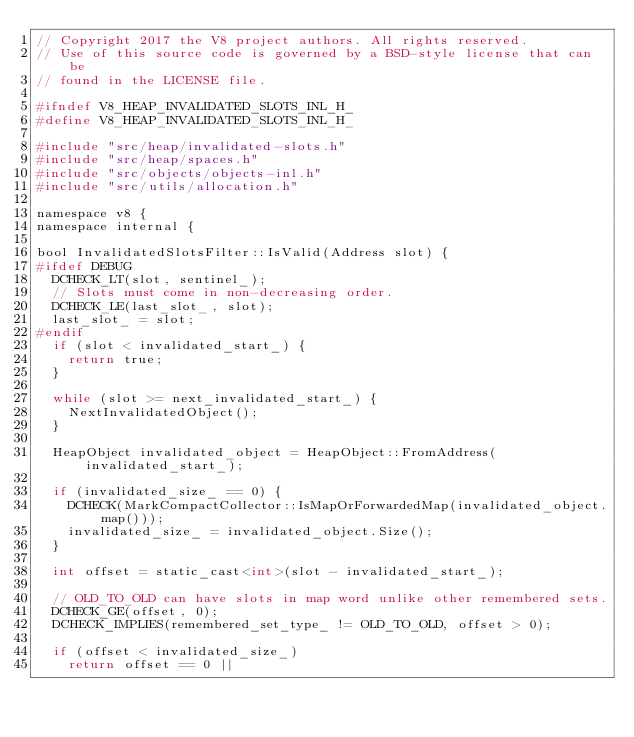Convert code to text. <code><loc_0><loc_0><loc_500><loc_500><_C_>// Copyright 2017 the V8 project authors. All rights reserved.
// Use of this source code is governed by a BSD-style license that can be
// found in the LICENSE file.

#ifndef V8_HEAP_INVALIDATED_SLOTS_INL_H_
#define V8_HEAP_INVALIDATED_SLOTS_INL_H_

#include "src/heap/invalidated-slots.h"
#include "src/heap/spaces.h"
#include "src/objects/objects-inl.h"
#include "src/utils/allocation.h"

namespace v8 {
namespace internal {

bool InvalidatedSlotsFilter::IsValid(Address slot) {
#ifdef DEBUG
  DCHECK_LT(slot, sentinel_);
  // Slots must come in non-decreasing order.
  DCHECK_LE(last_slot_, slot);
  last_slot_ = slot;
#endif
  if (slot < invalidated_start_) {
    return true;
  }

  while (slot >= next_invalidated_start_) {
    NextInvalidatedObject();
  }

  HeapObject invalidated_object = HeapObject::FromAddress(invalidated_start_);

  if (invalidated_size_ == 0) {
    DCHECK(MarkCompactCollector::IsMapOrForwardedMap(invalidated_object.map()));
    invalidated_size_ = invalidated_object.Size();
  }

  int offset = static_cast<int>(slot - invalidated_start_);

  // OLD_TO_OLD can have slots in map word unlike other remembered sets.
  DCHECK_GE(offset, 0);
  DCHECK_IMPLIES(remembered_set_type_ != OLD_TO_OLD, offset > 0);

  if (offset < invalidated_size_)
    return offset == 0 ||</code> 